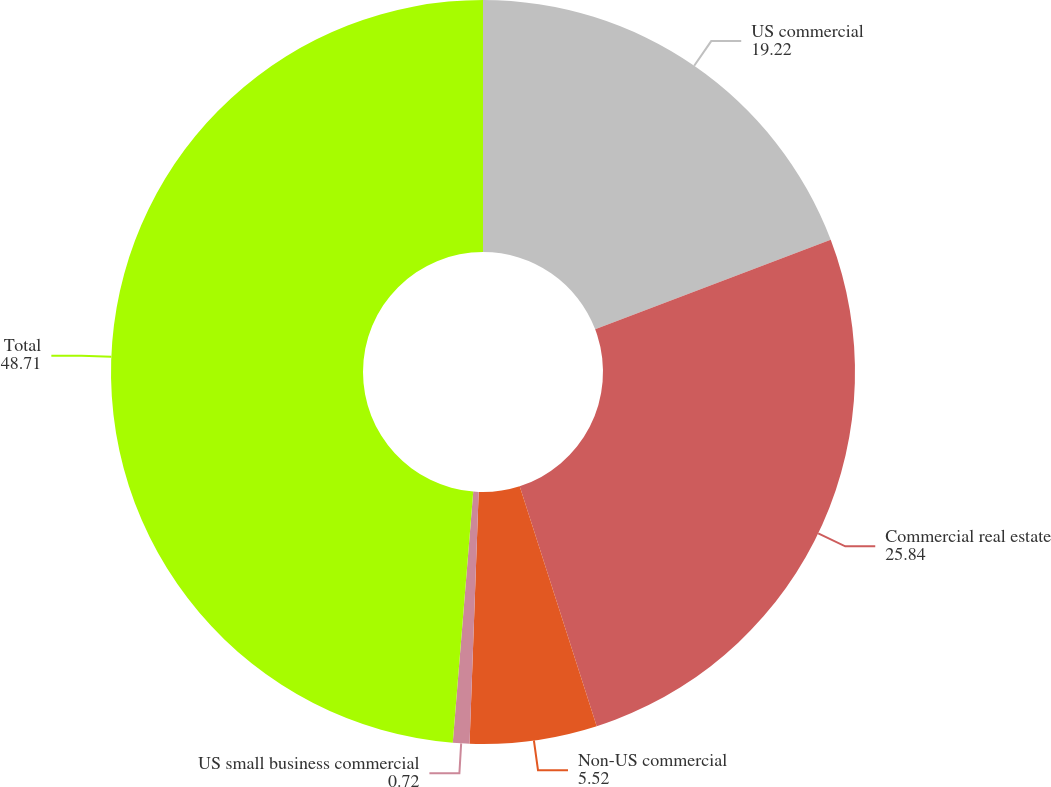Convert chart to OTSL. <chart><loc_0><loc_0><loc_500><loc_500><pie_chart><fcel>US commercial<fcel>Commercial real estate<fcel>Non-US commercial<fcel>US small business commercial<fcel>Total<nl><fcel>19.22%<fcel>25.84%<fcel>5.52%<fcel>0.72%<fcel>48.71%<nl></chart> 